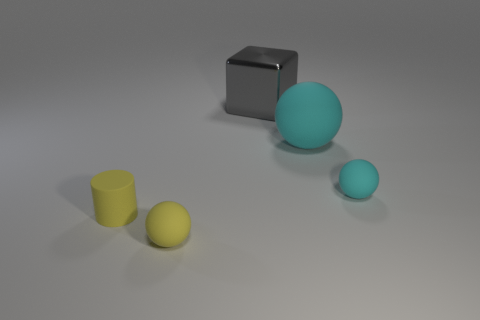Add 4 cubes. How many objects exist? 9 Subtract all red balls. Subtract all green cylinders. How many balls are left? 3 Subtract all blocks. How many objects are left? 4 Add 5 yellow rubber objects. How many yellow rubber objects are left? 7 Add 1 tiny yellow cylinders. How many tiny yellow cylinders exist? 2 Subtract 0 red blocks. How many objects are left? 5 Subtract all large cyan matte things. Subtract all small cylinders. How many objects are left? 3 